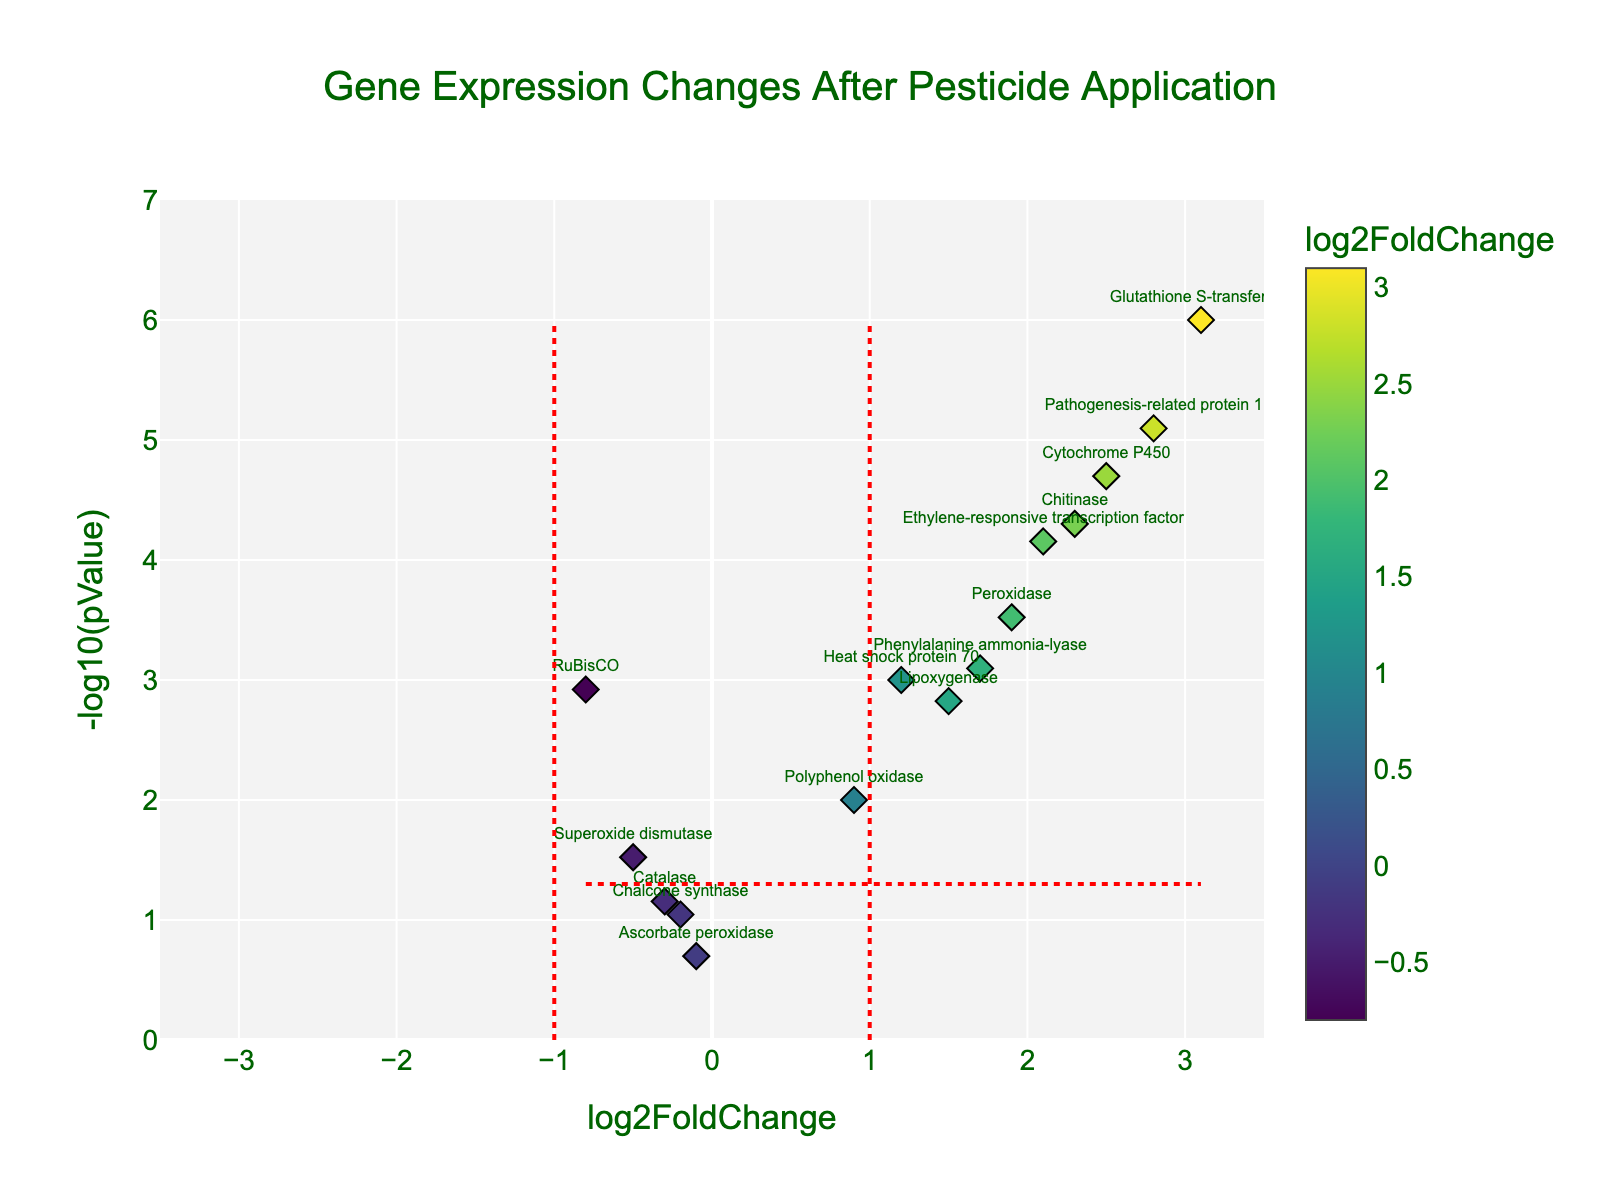What is the title of the plot? The title is displayed prominently at the top center of the plot. It reads "Gene Expression Changes After Pesticide Application".
Answer: Gene Expression Changes After Pesticide Application How many genes are shown with statistically significant changes (p-value < 0.05)? Statistically significant genes are those above the horizontal red line (y = -log10(0.05)). Count the genes above this line.
Answer: 11 Which gene shows the highest increase in expression? Look for the gene with the highest positive log2FoldChange value on the x-axis; it's marked with its name.
Answer: Glutathione S-transferase Which gene shows the most significant decrease in expression? The significance is indicated by the -log10(pValue). For the most significant decrease, look for the lowest log2FoldChange value and the highest -log10(pValue) line.
Answer: RuBisCO Are there any genes that did not show significant changes (p-value ≥ 0.05 and log2FoldChange between -1 and 1)? Look for genes within the log2FoldChange range of -1 to 1 and below the horizontal red line (indicating p-value ≥ 0.05). Count these genes.
Answer: 3 (Catalase, Chalcone synthase, Ascorbate peroxidase) Which gene has the highest -log10(pValue)? The gene with the largest y-value in the plot represents the highest -log10(pValue).
Answer: Glutathione S-transferase Is RuBisCO upregulated or downregulated after pesticide application? Examine the position of RuBisCO on the x-axis. Negative values indicate downregulation and positive values indicate upregulation.
Answer: Downregulated What is the log2FoldChange value for Peroxidase? Locate the Peroxidase gene in the plot and read the corresponding log2FoldChange value on the x-axis.
Answer: 1.9 How does Ethylene-responsive transcription factor compare to RuBisCO in terms of expression change? Compare the log2FoldChange values of both genes on the x-axis. Ethylene-responsive transcription factor has a positive log2FoldChange and RuBisCO has a negative log2FoldChange.
Answer: Ethylene-responsive transcription factor is upregulated, RuBisCO is downregulated What is the general trend of antioxidant genes (like Superoxide dismutase and Catalase) in terms of their expression changes? Examine the positions of Superoxide dismutase and Catalase on the x-axis to understand the trend in their expression changes.
Answer: Downregulated 